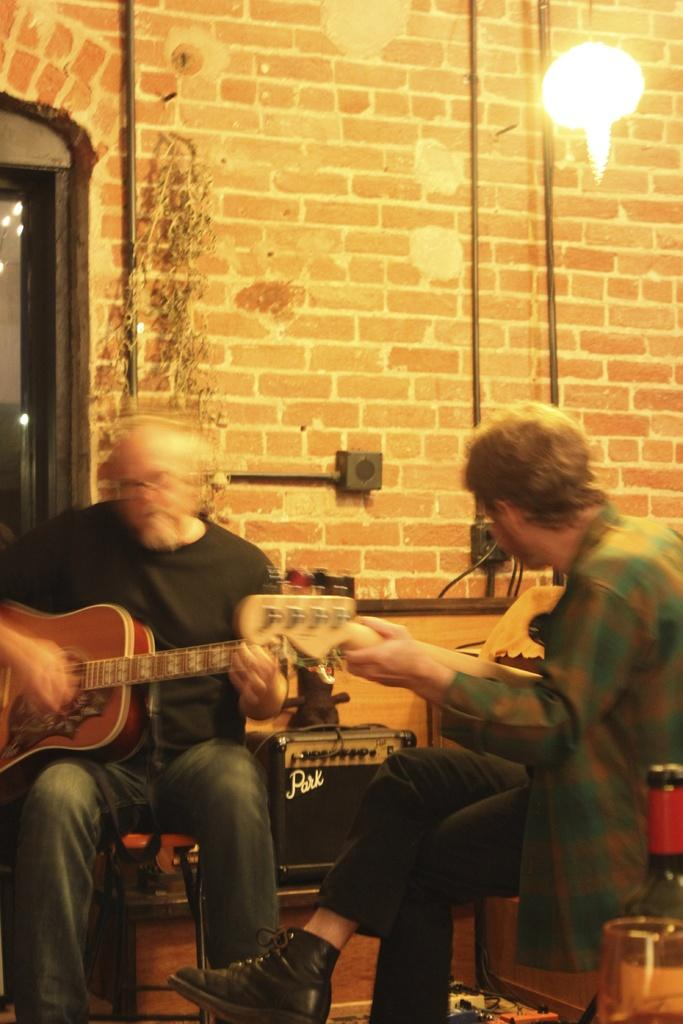How many people are in the image? There are two men in the image. What are the men doing in the image? The men are sitting and playing guitars. What objects are the men holding in the image? The men are holding guitars. What can be seen in the background of the image? There is a wall, a light, pipes, and a way or path in the background of the image. What type of oven can be seen in the image? There is no oven present in the image. How does the rainstorm affect the men playing guitars in the image? There is no rainstorm present in the image, so it does not affect the men playing guitars. 